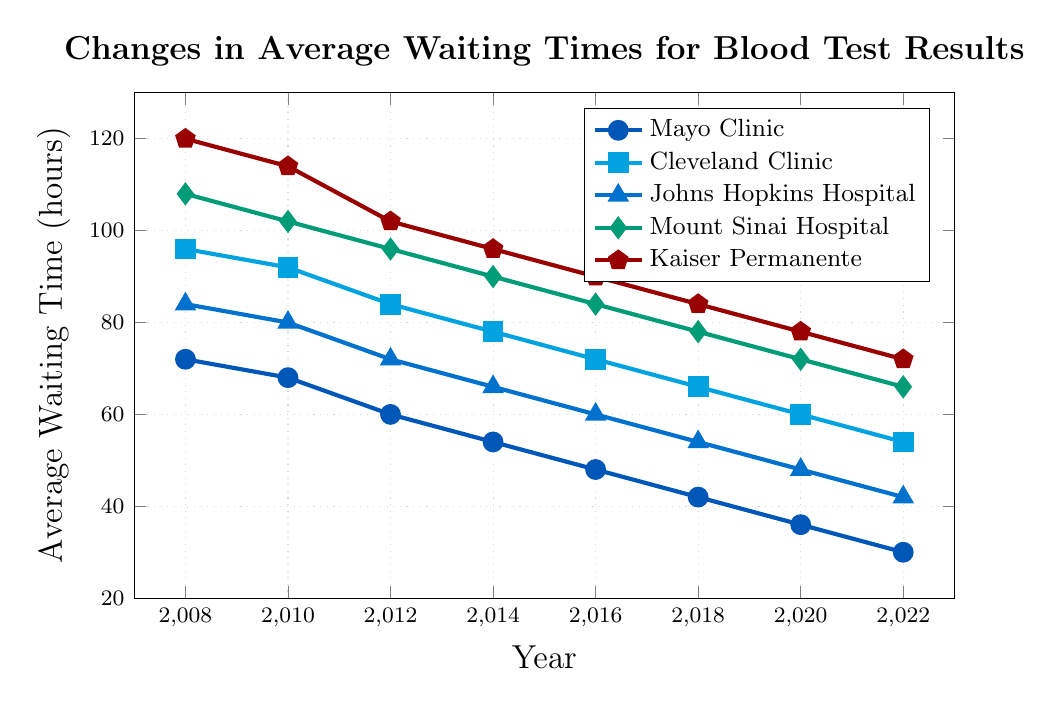Which facility had the longest average waiting time for blood test results in 2008? Based on the visual information from the figure, look at the data points for each facility in the year 2008 and identify the highest value. Mount Sinai Hospital has the highest value of 120 hours.
Answer: Mount Sinai Hospital Which facility showed the greatest improvement (decrease) in average waiting time from 2008 to 2022? Examining the data points for each facility from 2008 to 2022, calculate the difference in waiting times. The calculations are: Mayo Clinic (72-30=42), Cleveland Clinic (96-54=42), Johns Hopkins Hospital (84-42=42), Mount Sinai Hospital (108-66=42), Kaiser Permanente (120-72=48). Kaiser Permanente has the greatest difference of 48 hours.
Answer: Kaiser Permanente What is the average waiting time for blood test results in 2022 across all facilities? Add up the 2022 waiting times for all facilities (30 + 54 + 42 + 66 + 72) and divide by the number of facilities (5). The sum is 264, and the average is 264/5 = 52.8 hours.
Answer: 52.8 hours Which facility had a lower average waiting time in 2012: Mayo Clinic or Cleveland Clinic? Compare the 2012 data points for Mayo Clinic and Cleveland Clinic. Mayo Clinic has 60 hours, and Cleveland Clinic has 84 hours. Mayo Clinic is lower.
Answer: Mayo Clinic Between 2014 and 2016, which facility had a greater decrease in average waiting times: Johns Hopkins Hospital or Mount Sinai Hospital? Calculate the difference between the waiting times in 2014 and 2016 for both facilities. Johns Hopkins Hospital (66-60=6) and Mount Sinai Hospital (90-84=6). Both facilities had an equal decrease of 6 hours.
Answer: Both are equal In what year did Kaiser Permanente's average waiting time first drop below 100 hours? Review the waiting times for Kaiser Permanente for each year until it drops below 100 hours. In 2012, it is 102 hours, and in 2014, it drops to 96 hours.
Answer: 2014 How many years did it take Mayo Clinic to reduce their average waiting time by 50% from the year 2008? Calculate 50% of the 2008 waiting time for Mayo Clinic (50% of 72 is 36). Check when Mayo Clinic first has 36 hours or less. In 2020, the waiting time is 36 hours. The difference between 2020 and 2008 is 12 years.
Answer: 12 years 